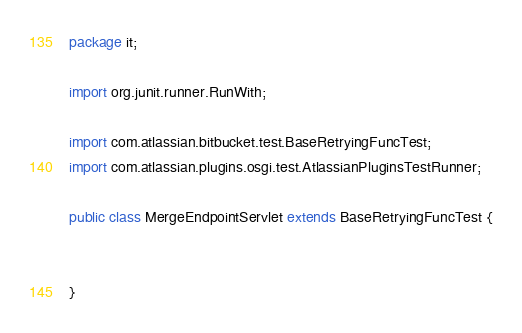<code> <loc_0><loc_0><loc_500><loc_500><_Java_>package it;

import org.junit.runner.RunWith;

import com.atlassian.bitbucket.test.BaseRetryingFuncTest;
import com.atlassian.plugins.osgi.test.AtlassianPluginsTestRunner;

public class MergeEndpointServlet extends BaseRetryingFuncTest {


}
</code> 